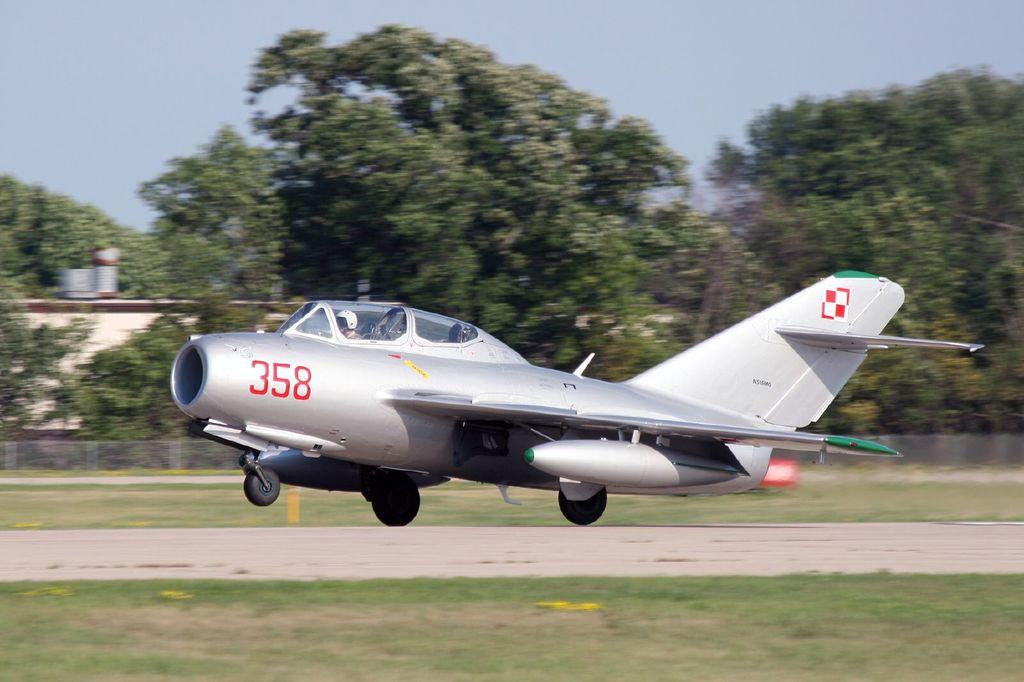What is the main subject of the image? The main subject of the image is persons in an aeroplane. Where is the aeroplane located in the image? The aeroplane is in the center of the image. What can be seen at the bottom of the image? There is a runway and grass visible at the bottom of the image. What is visible in the background of the image? Trees, at least one building, grass, and the sky are visible in the background of the image. What type of treatment is being administered in the alley in the image? There is no alley or treatment present in the image; it features an aeroplane with persons inside and a background with trees, a building, grass, and the sky. What type of apparel are the persons wearing in the image? The provided facts do not mention the apparel of the persons in the aeroplane, so it cannot be determined from the image. 